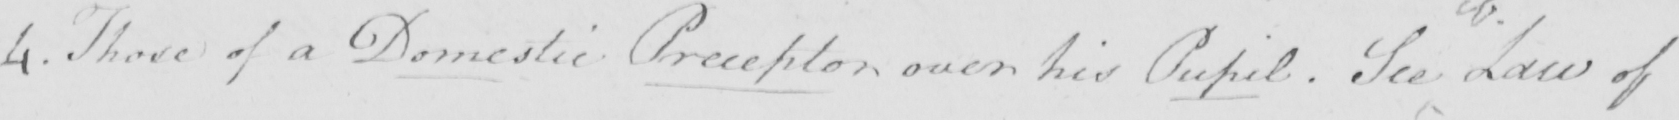What does this handwritten line say? 4 . Those of a Domestic Preceptor over his Pupil  . See Law of 